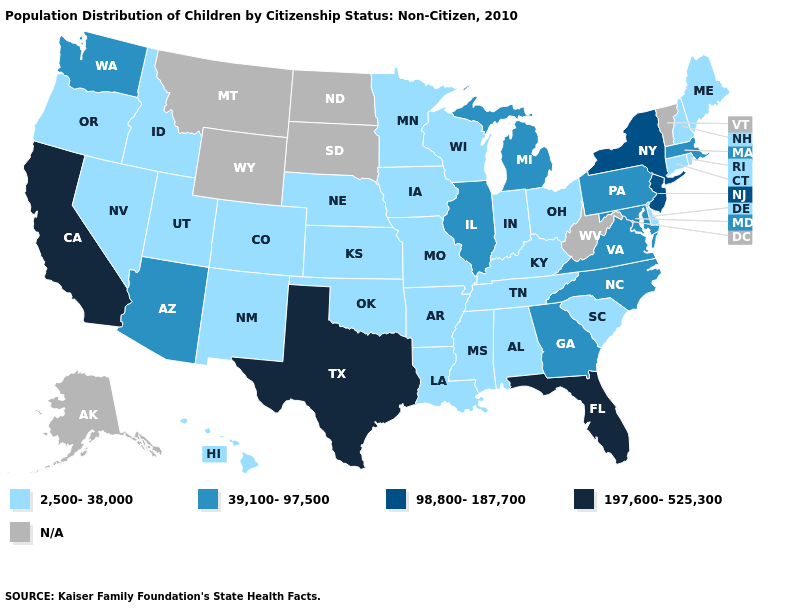Does the map have missing data?
Give a very brief answer. Yes. What is the value of Wyoming?
Answer briefly. N/A. Name the states that have a value in the range N/A?
Keep it brief. Alaska, Montana, North Dakota, South Dakota, Vermont, West Virginia, Wyoming. What is the value of Washington?
Short answer required. 39,100-97,500. Does Iowa have the lowest value in the USA?
Concise answer only. Yes. Name the states that have a value in the range N/A?
Give a very brief answer. Alaska, Montana, North Dakota, South Dakota, Vermont, West Virginia, Wyoming. What is the lowest value in states that border Nevada?
Keep it brief. 2,500-38,000. Name the states that have a value in the range N/A?
Give a very brief answer. Alaska, Montana, North Dakota, South Dakota, Vermont, West Virginia, Wyoming. What is the value of Wyoming?
Give a very brief answer. N/A. Name the states that have a value in the range 197,600-525,300?
Be succinct. California, Florida, Texas. Which states have the lowest value in the USA?
Be succinct. Alabama, Arkansas, Colorado, Connecticut, Delaware, Hawaii, Idaho, Indiana, Iowa, Kansas, Kentucky, Louisiana, Maine, Minnesota, Mississippi, Missouri, Nebraska, Nevada, New Hampshire, New Mexico, Ohio, Oklahoma, Oregon, Rhode Island, South Carolina, Tennessee, Utah, Wisconsin. Name the states that have a value in the range 197,600-525,300?
Quick response, please. California, Florida, Texas. What is the lowest value in the West?
Keep it brief. 2,500-38,000. 